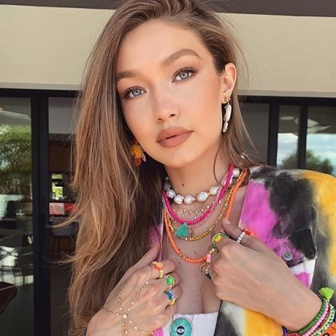If this image were the cover of a magazine, what kind of article would it feature? If this image were the cover of a magazine, it would likely feature an article on modern bohemian fashion. The vibrant tie-dye shirt, eclectic necklaces, and earrings, combined with the urban setting, would make for a fascinating piece on how contemporary fashion intersects with urban life. The article might delve into the resurgence of bohemian styles, offering tips on how to mix and match bold colors and accessories to create a unique, stylish look. 